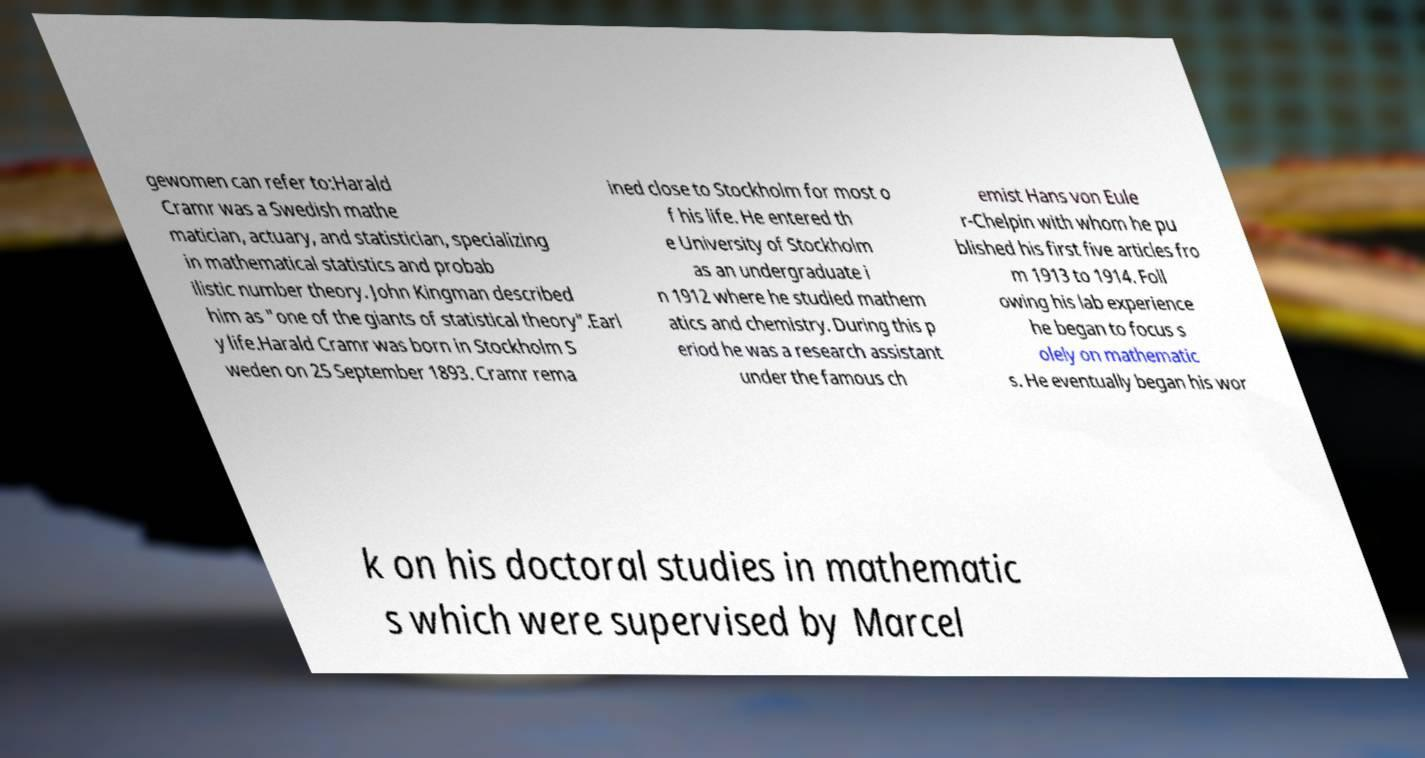What messages or text are displayed in this image? I need them in a readable, typed format. gewomen can refer to:Harald Cramr was a Swedish mathe matician, actuary, and statistician, specializing in mathematical statistics and probab ilistic number theory. John Kingman described him as "one of the giants of statistical theory".Earl y life.Harald Cramr was born in Stockholm S weden on 25 September 1893. Cramr rema ined close to Stockholm for most o f his life. He entered th e University of Stockholm as an undergraduate i n 1912 where he studied mathem atics and chemistry. During this p eriod he was a research assistant under the famous ch emist Hans von Eule r-Chelpin with whom he pu blished his first five articles fro m 1913 to 1914. Foll owing his lab experience he began to focus s olely on mathematic s. He eventually began his wor k on his doctoral studies in mathematic s which were supervised by Marcel 